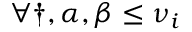<formula> <loc_0><loc_0><loc_500><loc_500>\forall \dag , \alpha , \beta \leq \nu _ { i }</formula> 